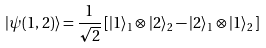<formula> <loc_0><loc_0><loc_500><loc_500>| \psi ( 1 , 2 ) \rangle = \frac { 1 } { \sqrt { 2 } } \, [ | 1 \rangle _ { 1 } \otimes | 2 \rangle _ { 2 } - | 2 \rangle _ { 1 } \otimes | 1 \rangle _ { 2 } \, ]</formula> 